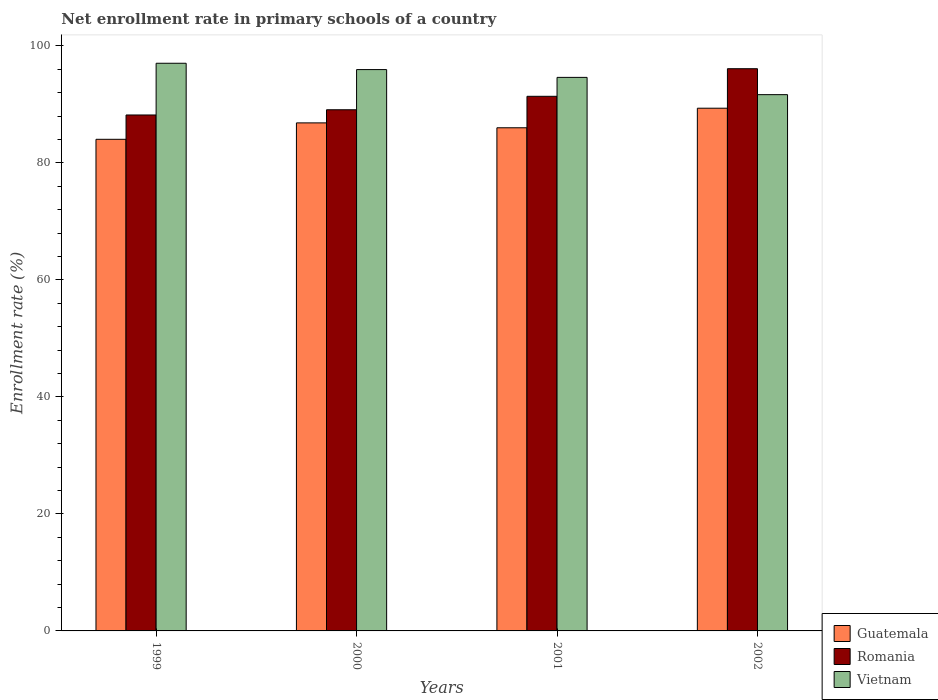How many different coloured bars are there?
Give a very brief answer. 3. How many groups of bars are there?
Make the answer very short. 4. How many bars are there on the 1st tick from the left?
Provide a short and direct response. 3. How many bars are there on the 2nd tick from the right?
Keep it short and to the point. 3. In how many cases, is the number of bars for a given year not equal to the number of legend labels?
Ensure brevity in your answer.  0. What is the enrollment rate in primary schools in Romania in 2001?
Ensure brevity in your answer.  91.38. Across all years, what is the maximum enrollment rate in primary schools in Romania?
Provide a succinct answer. 96.09. Across all years, what is the minimum enrollment rate in primary schools in Vietnam?
Ensure brevity in your answer.  91.66. In which year was the enrollment rate in primary schools in Romania maximum?
Make the answer very short. 2002. In which year was the enrollment rate in primary schools in Romania minimum?
Your response must be concise. 1999. What is the total enrollment rate in primary schools in Romania in the graph?
Make the answer very short. 364.73. What is the difference between the enrollment rate in primary schools in Romania in 2000 and that in 2001?
Keep it short and to the point. -2.3. What is the difference between the enrollment rate in primary schools in Vietnam in 2000 and the enrollment rate in primary schools in Guatemala in 1999?
Your answer should be compact. 11.92. What is the average enrollment rate in primary schools in Guatemala per year?
Provide a succinct answer. 86.55. In the year 1999, what is the difference between the enrollment rate in primary schools in Guatemala and enrollment rate in primary schools in Vietnam?
Your response must be concise. -13. What is the ratio of the enrollment rate in primary schools in Romania in 1999 to that in 2001?
Provide a short and direct response. 0.97. What is the difference between the highest and the second highest enrollment rate in primary schools in Romania?
Offer a very short reply. 4.72. What is the difference between the highest and the lowest enrollment rate in primary schools in Guatemala?
Provide a succinct answer. 5.31. In how many years, is the enrollment rate in primary schools in Vietnam greater than the average enrollment rate in primary schools in Vietnam taken over all years?
Your response must be concise. 2. Is the sum of the enrollment rate in primary schools in Romania in 1999 and 2001 greater than the maximum enrollment rate in primary schools in Guatemala across all years?
Ensure brevity in your answer.  Yes. What does the 1st bar from the left in 2000 represents?
Provide a succinct answer. Guatemala. What does the 1st bar from the right in 2001 represents?
Provide a succinct answer. Vietnam. How many legend labels are there?
Your answer should be very brief. 3. How are the legend labels stacked?
Keep it short and to the point. Vertical. What is the title of the graph?
Ensure brevity in your answer.  Net enrollment rate in primary schools of a country. What is the label or title of the Y-axis?
Offer a terse response. Enrollment rate (%). What is the Enrollment rate (%) in Guatemala in 1999?
Your answer should be very brief. 84.03. What is the Enrollment rate (%) of Romania in 1999?
Provide a succinct answer. 88.18. What is the Enrollment rate (%) of Vietnam in 1999?
Make the answer very short. 97.02. What is the Enrollment rate (%) of Guatemala in 2000?
Make the answer very short. 86.83. What is the Enrollment rate (%) in Romania in 2000?
Keep it short and to the point. 89.08. What is the Enrollment rate (%) of Vietnam in 2000?
Your answer should be very brief. 95.94. What is the Enrollment rate (%) of Guatemala in 2001?
Offer a terse response. 86. What is the Enrollment rate (%) in Romania in 2001?
Keep it short and to the point. 91.38. What is the Enrollment rate (%) in Vietnam in 2001?
Your answer should be compact. 94.61. What is the Enrollment rate (%) in Guatemala in 2002?
Give a very brief answer. 89.34. What is the Enrollment rate (%) in Romania in 2002?
Ensure brevity in your answer.  96.09. What is the Enrollment rate (%) in Vietnam in 2002?
Provide a succinct answer. 91.66. Across all years, what is the maximum Enrollment rate (%) of Guatemala?
Provide a short and direct response. 89.34. Across all years, what is the maximum Enrollment rate (%) in Romania?
Provide a short and direct response. 96.09. Across all years, what is the maximum Enrollment rate (%) in Vietnam?
Your response must be concise. 97.02. Across all years, what is the minimum Enrollment rate (%) in Guatemala?
Provide a succinct answer. 84.03. Across all years, what is the minimum Enrollment rate (%) in Romania?
Your answer should be compact. 88.18. Across all years, what is the minimum Enrollment rate (%) of Vietnam?
Make the answer very short. 91.66. What is the total Enrollment rate (%) of Guatemala in the graph?
Offer a very short reply. 346.2. What is the total Enrollment rate (%) of Romania in the graph?
Give a very brief answer. 364.73. What is the total Enrollment rate (%) of Vietnam in the graph?
Offer a terse response. 379.24. What is the difference between the Enrollment rate (%) in Guatemala in 1999 and that in 2000?
Your answer should be compact. -2.81. What is the difference between the Enrollment rate (%) in Romania in 1999 and that in 2000?
Ensure brevity in your answer.  -0.89. What is the difference between the Enrollment rate (%) in Vietnam in 1999 and that in 2000?
Offer a very short reply. 1.08. What is the difference between the Enrollment rate (%) of Guatemala in 1999 and that in 2001?
Provide a succinct answer. -1.97. What is the difference between the Enrollment rate (%) in Romania in 1999 and that in 2001?
Offer a terse response. -3.19. What is the difference between the Enrollment rate (%) of Vietnam in 1999 and that in 2001?
Provide a short and direct response. 2.41. What is the difference between the Enrollment rate (%) of Guatemala in 1999 and that in 2002?
Offer a terse response. -5.31. What is the difference between the Enrollment rate (%) in Romania in 1999 and that in 2002?
Keep it short and to the point. -7.91. What is the difference between the Enrollment rate (%) of Vietnam in 1999 and that in 2002?
Offer a very short reply. 5.37. What is the difference between the Enrollment rate (%) of Guatemala in 2000 and that in 2001?
Make the answer very short. 0.83. What is the difference between the Enrollment rate (%) of Romania in 2000 and that in 2001?
Give a very brief answer. -2.3. What is the difference between the Enrollment rate (%) in Vietnam in 2000 and that in 2001?
Ensure brevity in your answer.  1.33. What is the difference between the Enrollment rate (%) of Guatemala in 2000 and that in 2002?
Ensure brevity in your answer.  -2.51. What is the difference between the Enrollment rate (%) in Romania in 2000 and that in 2002?
Your answer should be compact. -7.02. What is the difference between the Enrollment rate (%) of Vietnam in 2000 and that in 2002?
Offer a very short reply. 4.29. What is the difference between the Enrollment rate (%) in Guatemala in 2001 and that in 2002?
Offer a very short reply. -3.34. What is the difference between the Enrollment rate (%) of Romania in 2001 and that in 2002?
Keep it short and to the point. -4.72. What is the difference between the Enrollment rate (%) of Vietnam in 2001 and that in 2002?
Provide a succinct answer. 2.95. What is the difference between the Enrollment rate (%) in Guatemala in 1999 and the Enrollment rate (%) in Romania in 2000?
Provide a succinct answer. -5.05. What is the difference between the Enrollment rate (%) of Guatemala in 1999 and the Enrollment rate (%) of Vietnam in 2000?
Offer a very short reply. -11.92. What is the difference between the Enrollment rate (%) of Romania in 1999 and the Enrollment rate (%) of Vietnam in 2000?
Give a very brief answer. -7.76. What is the difference between the Enrollment rate (%) in Guatemala in 1999 and the Enrollment rate (%) in Romania in 2001?
Your answer should be compact. -7.35. What is the difference between the Enrollment rate (%) of Guatemala in 1999 and the Enrollment rate (%) of Vietnam in 2001?
Offer a terse response. -10.58. What is the difference between the Enrollment rate (%) of Romania in 1999 and the Enrollment rate (%) of Vietnam in 2001?
Make the answer very short. -6.43. What is the difference between the Enrollment rate (%) in Guatemala in 1999 and the Enrollment rate (%) in Romania in 2002?
Offer a very short reply. -12.07. What is the difference between the Enrollment rate (%) in Guatemala in 1999 and the Enrollment rate (%) in Vietnam in 2002?
Your answer should be very brief. -7.63. What is the difference between the Enrollment rate (%) of Romania in 1999 and the Enrollment rate (%) of Vietnam in 2002?
Your response must be concise. -3.47. What is the difference between the Enrollment rate (%) in Guatemala in 2000 and the Enrollment rate (%) in Romania in 2001?
Your response must be concise. -4.54. What is the difference between the Enrollment rate (%) in Guatemala in 2000 and the Enrollment rate (%) in Vietnam in 2001?
Provide a succinct answer. -7.78. What is the difference between the Enrollment rate (%) of Romania in 2000 and the Enrollment rate (%) of Vietnam in 2001?
Offer a very short reply. -5.53. What is the difference between the Enrollment rate (%) in Guatemala in 2000 and the Enrollment rate (%) in Romania in 2002?
Your answer should be compact. -9.26. What is the difference between the Enrollment rate (%) of Guatemala in 2000 and the Enrollment rate (%) of Vietnam in 2002?
Your answer should be very brief. -4.83. What is the difference between the Enrollment rate (%) in Romania in 2000 and the Enrollment rate (%) in Vietnam in 2002?
Ensure brevity in your answer.  -2.58. What is the difference between the Enrollment rate (%) of Guatemala in 2001 and the Enrollment rate (%) of Romania in 2002?
Provide a succinct answer. -10.1. What is the difference between the Enrollment rate (%) in Guatemala in 2001 and the Enrollment rate (%) in Vietnam in 2002?
Provide a succinct answer. -5.66. What is the difference between the Enrollment rate (%) of Romania in 2001 and the Enrollment rate (%) of Vietnam in 2002?
Offer a terse response. -0.28. What is the average Enrollment rate (%) of Guatemala per year?
Make the answer very short. 86.55. What is the average Enrollment rate (%) of Romania per year?
Provide a succinct answer. 91.18. What is the average Enrollment rate (%) of Vietnam per year?
Provide a short and direct response. 94.81. In the year 1999, what is the difference between the Enrollment rate (%) in Guatemala and Enrollment rate (%) in Romania?
Make the answer very short. -4.16. In the year 1999, what is the difference between the Enrollment rate (%) of Guatemala and Enrollment rate (%) of Vietnam?
Offer a very short reply. -13. In the year 1999, what is the difference between the Enrollment rate (%) in Romania and Enrollment rate (%) in Vietnam?
Your response must be concise. -8.84. In the year 2000, what is the difference between the Enrollment rate (%) in Guatemala and Enrollment rate (%) in Romania?
Ensure brevity in your answer.  -2.24. In the year 2000, what is the difference between the Enrollment rate (%) of Guatemala and Enrollment rate (%) of Vietnam?
Make the answer very short. -9.11. In the year 2000, what is the difference between the Enrollment rate (%) in Romania and Enrollment rate (%) in Vietnam?
Provide a short and direct response. -6.87. In the year 2001, what is the difference between the Enrollment rate (%) of Guatemala and Enrollment rate (%) of Romania?
Offer a terse response. -5.38. In the year 2001, what is the difference between the Enrollment rate (%) of Guatemala and Enrollment rate (%) of Vietnam?
Give a very brief answer. -8.61. In the year 2001, what is the difference between the Enrollment rate (%) of Romania and Enrollment rate (%) of Vietnam?
Your answer should be compact. -3.23. In the year 2002, what is the difference between the Enrollment rate (%) of Guatemala and Enrollment rate (%) of Romania?
Your response must be concise. -6.75. In the year 2002, what is the difference between the Enrollment rate (%) of Guatemala and Enrollment rate (%) of Vietnam?
Your answer should be very brief. -2.32. In the year 2002, what is the difference between the Enrollment rate (%) of Romania and Enrollment rate (%) of Vietnam?
Provide a short and direct response. 4.43. What is the ratio of the Enrollment rate (%) of Vietnam in 1999 to that in 2000?
Keep it short and to the point. 1.01. What is the ratio of the Enrollment rate (%) of Guatemala in 1999 to that in 2001?
Your answer should be compact. 0.98. What is the ratio of the Enrollment rate (%) of Romania in 1999 to that in 2001?
Your answer should be very brief. 0.97. What is the ratio of the Enrollment rate (%) of Vietnam in 1999 to that in 2001?
Ensure brevity in your answer.  1.03. What is the ratio of the Enrollment rate (%) in Guatemala in 1999 to that in 2002?
Ensure brevity in your answer.  0.94. What is the ratio of the Enrollment rate (%) in Romania in 1999 to that in 2002?
Make the answer very short. 0.92. What is the ratio of the Enrollment rate (%) in Vietnam in 1999 to that in 2002?
Provide a short and direct response. 1.06. What is the ratio of the Enrollment rate (%) of Guatemala in 2000 to that in 2001?
Provide a succinct answer. 1.01. What is the ratio of the Enrollment rate (%) in Romania in 2000 to that in 2001?
Keep it short and to the point. 0.97. What is the ratio of the Enrollment rate (%) in Vietnam in 2000 to that in 2001?
Your answer should be very brief. 1.01. What is the ratio of the Enrollment rate (%) of Guatemala in 2000 to that in 2002?
Your response must be concise. 0.97. What is the ratio of the Enrollment rate (%) of Romania in 2000 to that in 2002?
Your response must be concise. 0.93. What is the ratio of the Enrollment rate (%) of Vietnam in 2000 to that in 2002?
Your response must be concise. 1.05. What is the ratio of the Enrollment rate (%) of Guatemala in 2001 to that in 2002?
Give a very brief answer. 0.96. What is the ratio of the Enrollment rate (%) in Romania in 2001 to that in 2002?
Your answer should be compact. 0.95. What is the ratio of the Enrollment rate (%) in Vietnam in 2001 to that in 2002?
Offer a very short reply. 1.03. What is the difference between the highest and the second highest Enrollment rate (%) in Guatemala?
Ensure brevity in your answer.  2.51. What is the difference between the highest and the second highest Enrollment rate (%) of Romania?
Ensure brevity in your answer.  4.72. What is the difference between the highest and the second highest Enrollment rate (%) in Vietnam?
Give a very brief answer. 1.08. What is the difference between the highest and the lowest Enrollment rate (%) of Guatemala?
Provide a short and direct response. 5.31. What is the difference between the highest and the lowest Enrollment rate (%) of Romania?
Your answer should be very brief. 7.91. What is the difference between the highest and the lowest Enrollment rate (%) of Vietnam?
Your answer should be very brief. 5.37. 